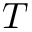Convert formula to latex. <formula><loc_0><loc_0><loc_500><loc_500>T</formula> 